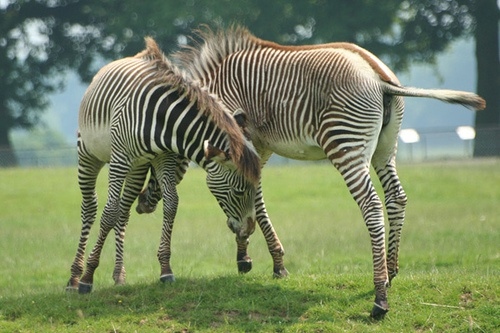Describe the objects in this image and their specific colors. I can see zebra in lightblue, gray, darkgray, and black tones and zebra in lightblue, black, gray, darkgreen, and darkgray tones in this image. 